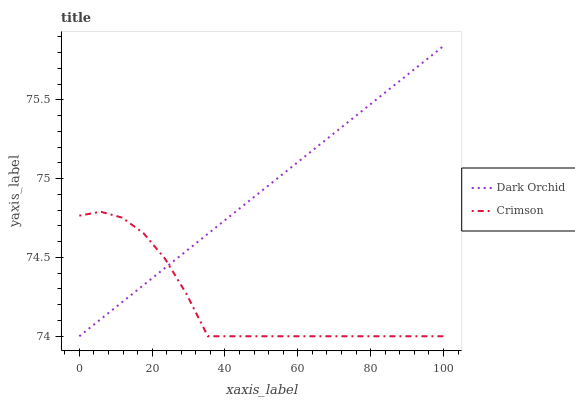Does Crimson have the minimum area under the curve?
Answer yes or no. Yes. Does Dark Orchid have the maximum area under the curve?
Answer yes or no. Yes. Does Dark Orchid have the minimum area under the curve?
Answer yes or no. No. Is Dark Orchid the smoothest?
Answer yes or no. Yes. Is Crimson the roughest?
Answer yes or no. Yes. Is Dark Orchid the roughest?
Answer yes or no. No. Does Crimson have the lowest value?
Answer yes or no. Yes. Does Dark Orchid have the highest value?
Answer yes or no. Yes. Does Dark Orchid intersect Crimson?
Answer yes or no. Yes. Is Dark Orchid less than Crimson?
Answer yes or no. No. Is Dark Orchid greater than Crimson?
Answer yes or no. No. 